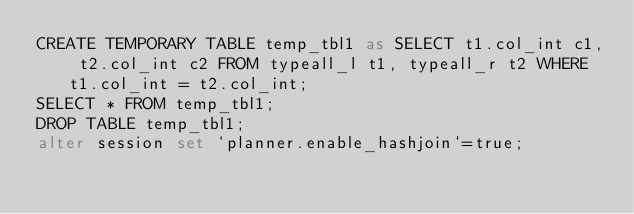Convert code to text. <code><loc_0><loc_0><loc_500><loc_500><_SQL_>CREATE TEMPORARY TABLE temp_tbl1 as SELECT t1.col_int c1, t2.col_int c2 FROM typeall_l t1, typeall_r t2 WHERE t1.col_int = t2.col_int;
SELECT * FROM temp_tbl1;
DROP TABLE temp_tbl1;
alter session set `planner.enable_hashjoin`=true;
</code> 